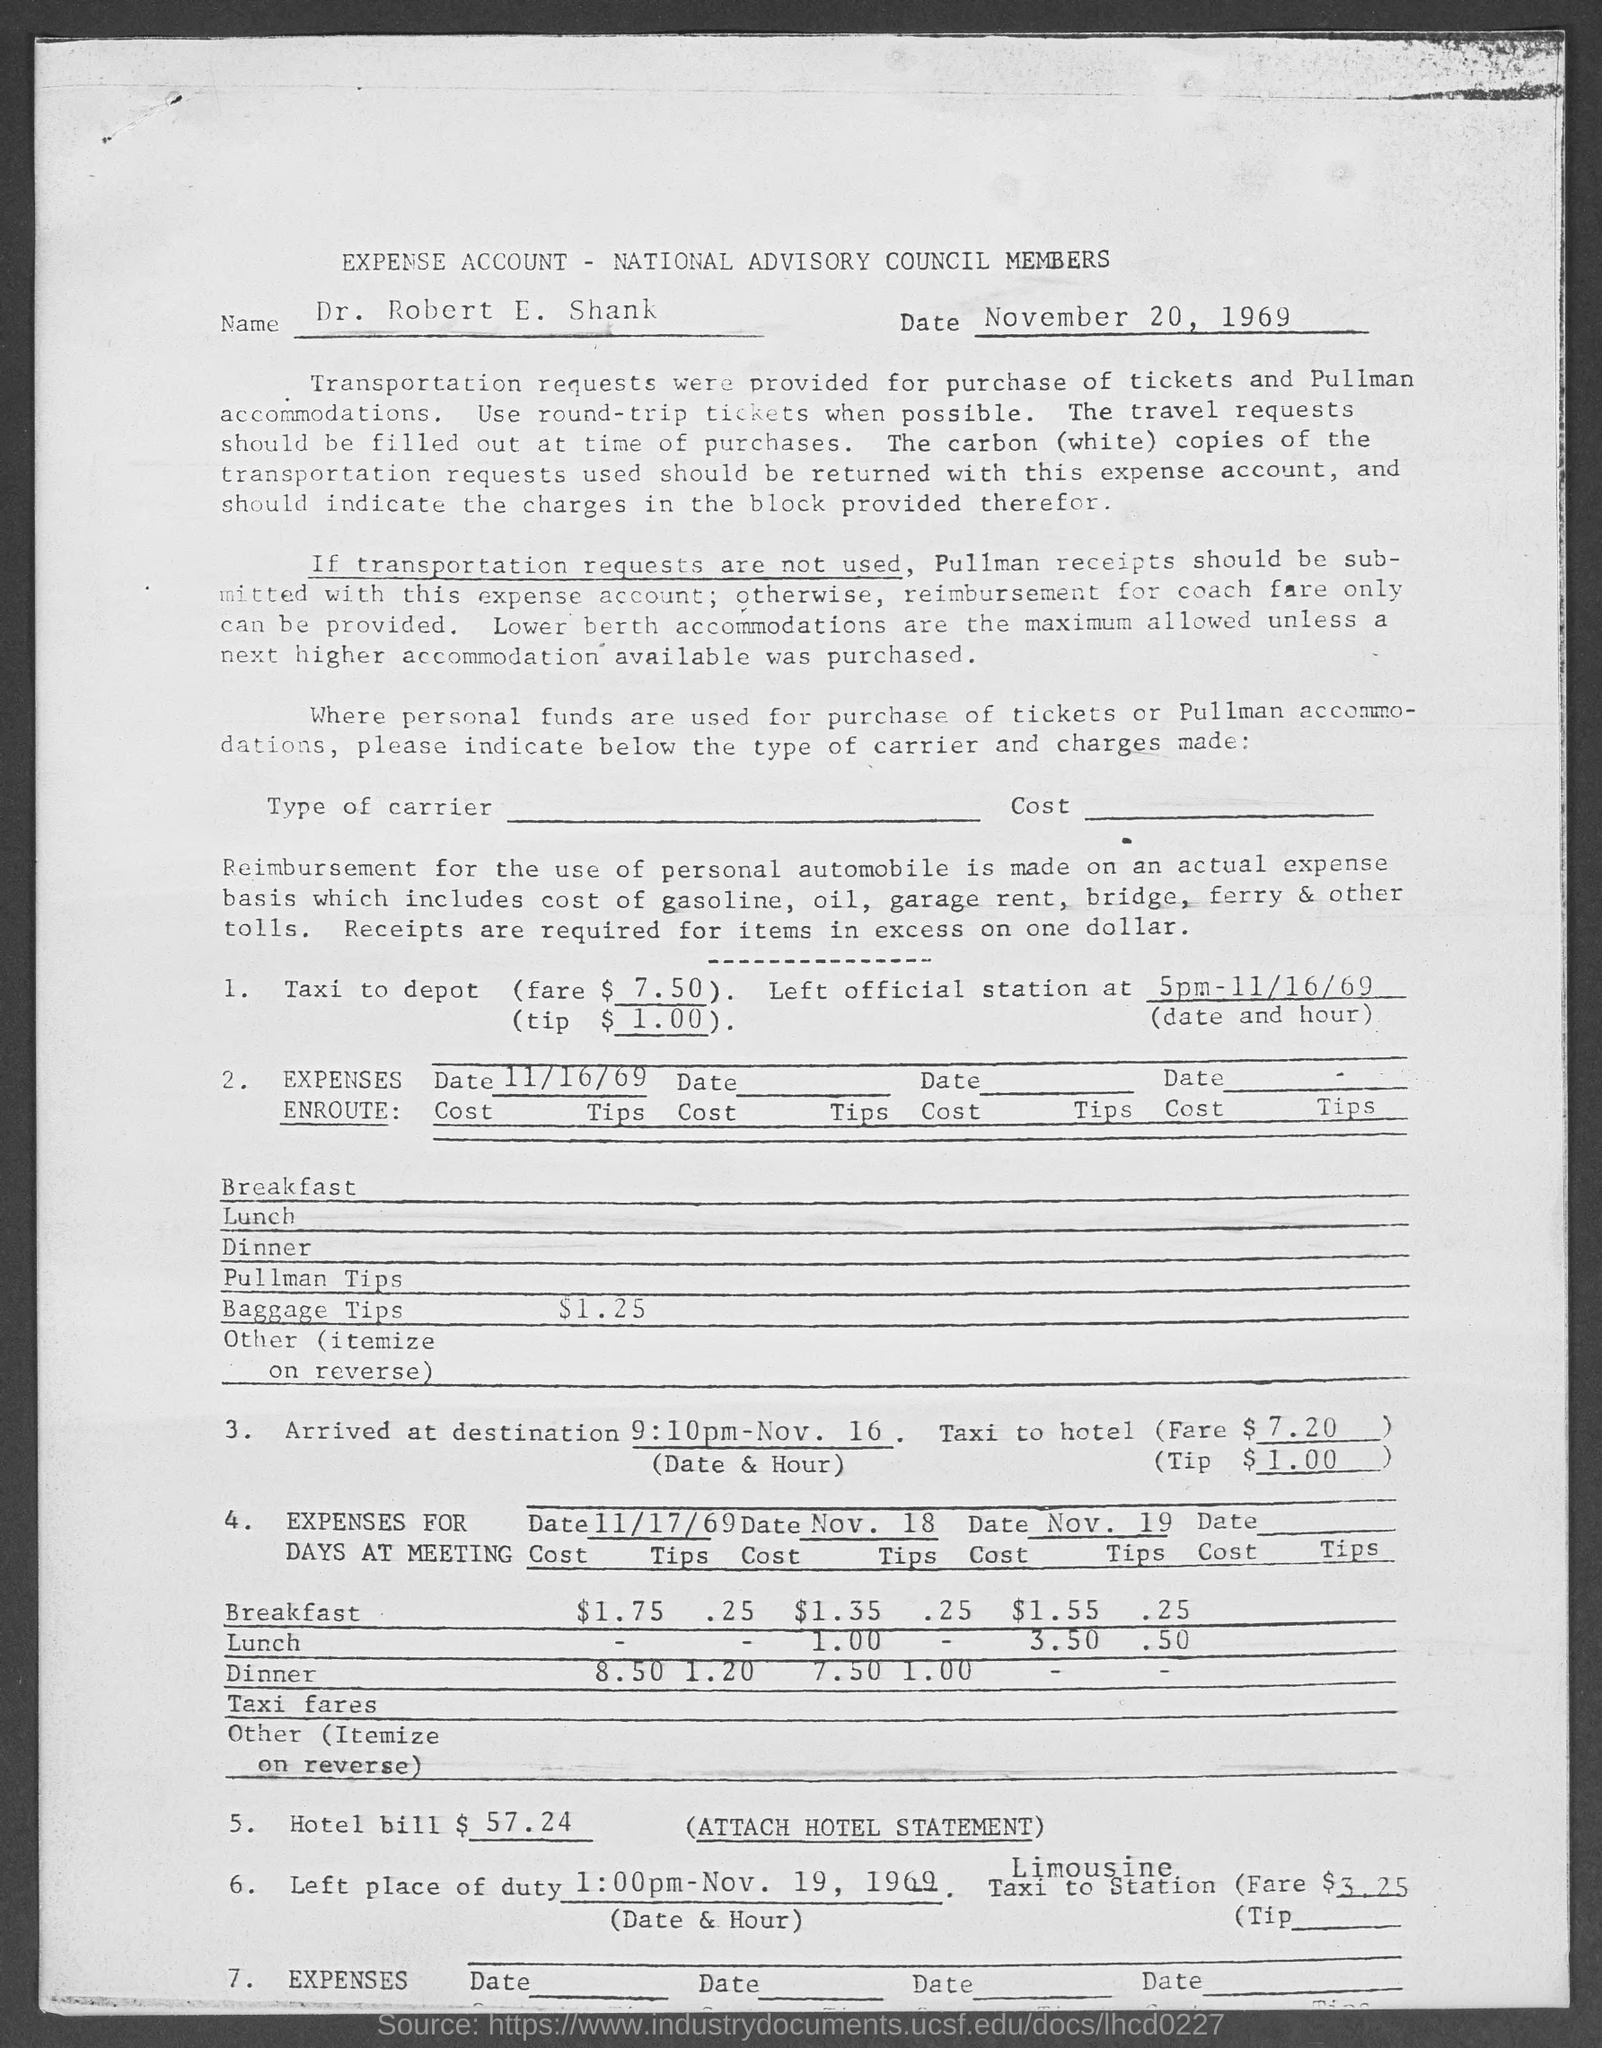Draw attention to some important aspects in this diagram. The expense account bears the name 'Dr. Robert E. Shank'. On November 20, 1969, the expense account recorded the date. 